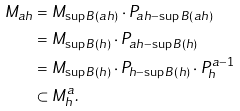<formula> <loc_0><loc_0><loc_500><loc_500>M _ { a h } & = M _ { \sup B ( a h ) } \cdot P _ { a h - \sup B ( a h ) } \\ & = M _ { \sup B ( h ) } \cdot P _ { a h - \sup B ( h ) } \\ & = M _ { \sup B ( h ) } \cdot P _ { h - \sup B ( h ) } \cdot P _ { h } ^ { a - 1 } \\ & \subset M _ { h } ^ { a } .</formula> 